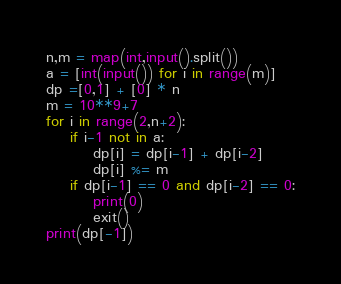<code> <loc_0><loc_0><loc_500><loc_500><_Python_>n,m = map(int,input().split())
a = [int(input()) for i in range(m)]
dp =[0,1] + [0] * n
m = 10**9+7
for i in range(2,n+2):
    if i-1 not in a:
        dp[i] = dp[i-1] + dp[i-2]
        dp[i] %= m
    if dp[i-1] == 0 and dp[i-2] == 0:
        print(0)
        exit()
print(dp[-1])</code> 